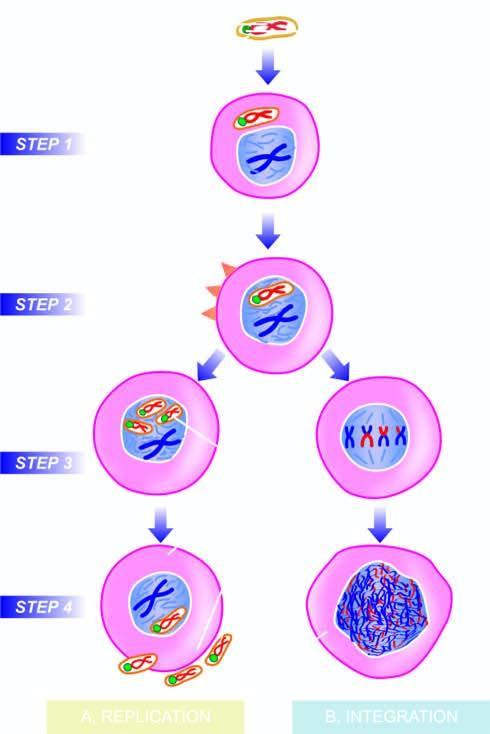re other components of virion formed?
Answer the question using a single word or phrase. Yes 